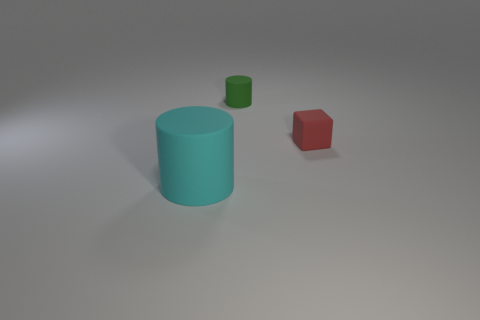Add 3 tiny cyan rubber cylinders. How many objects exist? 6 Subtract all blocks. How many objects are left? 2 Subtract all red things. Subtract all green cylinders. How many objects are left? 1 Add 1 tiny green matte cylinders. How many tiny green matte cylinders are left? 2 Add 3 small red spheres. How many small red spheres exist? 3 Subtract 0 blue spheres. How many objects are left? 3 